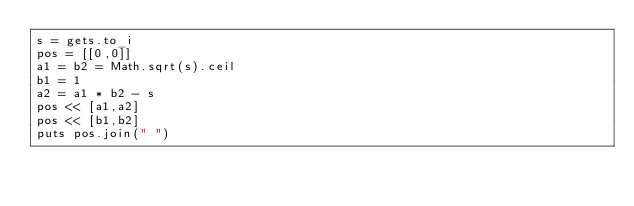<code> <loc_0><loc_0><loc_500><loc_500><_Ruby_>s = gets.to_i
pos = [[0,0]]
a1 = b2 = Math.sqrt(s).ceil
b1 = 1
a2 = a1 * b2 - s
pos << [a1,a2]
pos << [b1,b2]
puts pos.join(" ")
</code> 